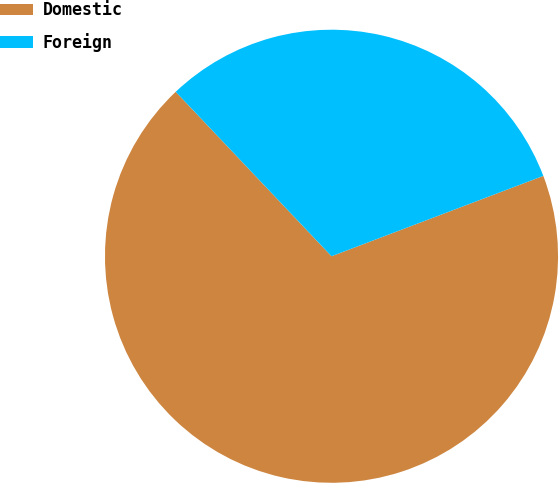Convert chart to OTSL. <chart><loc_0><loc_0><loc_500><loc_500><pie_chart><fcel>Domestic<fcel>Foreign<nl><fcel>68.7%<fcel>31.3%<nl></chart> 